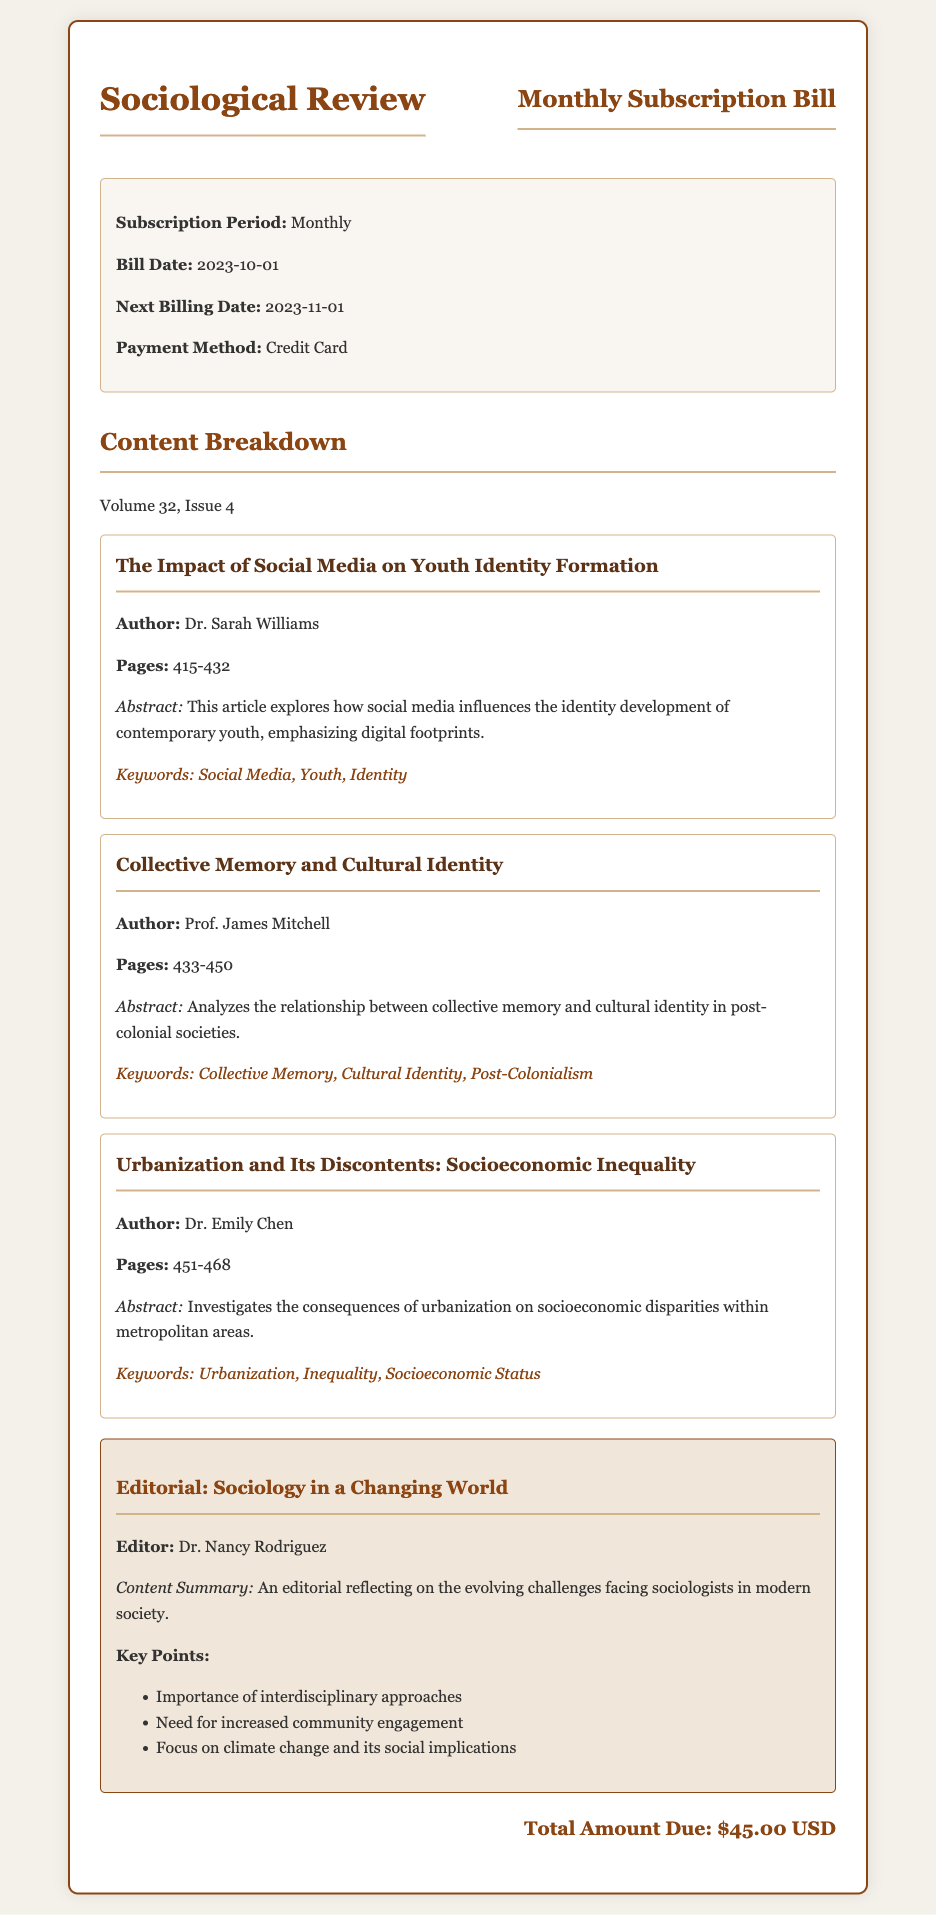What is the subscription period? The subscription period is mentioned at the beginning of the bill under the bill details section.
Answer: Monthly What is the bill date? The bill date is specified in the bill details section, indicating when the current bill was issued.
Answer: 2023-10-01 Who is the author of the first article? The first article's details include the author's name, which is provided in the article section.
Answer: Dr. Sarah Williams What are the pages of the article "Collective Memory and Cultural Identity"? The ranges of pages for each article are listed in their respective sections, showing where the article is located in the journal.
Answer: 433-450 What is the total amount due? The total amount due is stated clearly at the end of the document, summarizing the financial obligation.
Answer: $45.00 USD What is the title of the editorial? The title of the editorial is provided in the editorial section of the document.
Answer: Sociology in a Changing World What is one of the key points from the editorial? The document lists several key points in the editorial section, highlighting important topics discussed.
Answer: Importance of interdisciplinary approaches How many articles are listed in the content breakdown? The number of articles is determined by counting the articles listed in the content breakdown section.
Answer: Three 